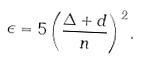Convert formula to latex. <formula><loc_0><loc_0><loc_500><loc_500>\epsilon = 5 \left ( \frac { \Delta + d } { n } \right ) ^ { 2 } .</formula> 